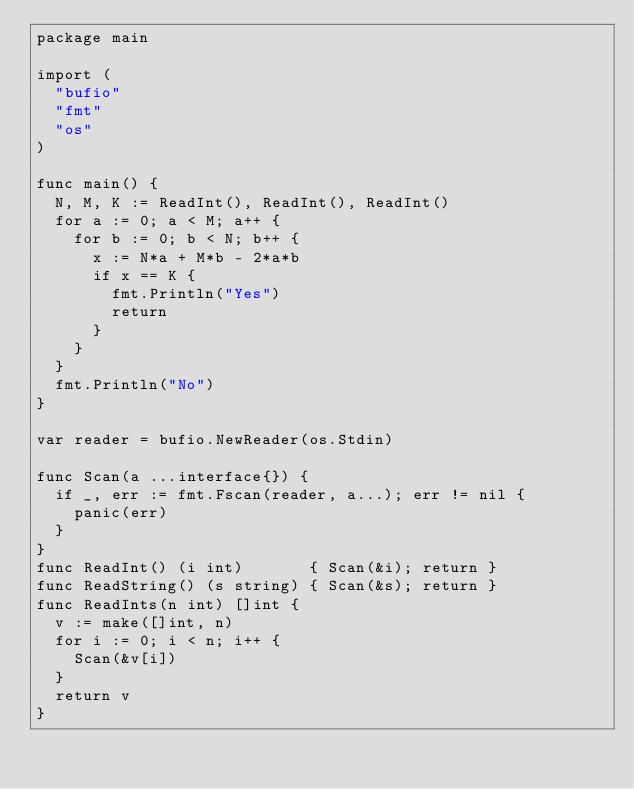<code> <loc_0><loc_0><loc_500><loc_500><_Go_>package main

import (
	"bufio"
	"fmt"
	"os"
)

func main() {
	N, M, K := ReadInt(), ReadInt(), ReadInt()
	for a := 0; a < M; a++ {
		for b := 0; b < N; b++ {
			x := N*a + M*b - 2*a*b
			if x == K {
				fmt.Println("Yes")
				return
			}
		}
	}
	fmt.Println("No")
}

var reader = bufio.NewReader(os.Stdin)

func Scan(a ...interface{}) {
	if _, err := fmt.Fscan(reader, a...); err != nil {
		panic(err)
	}
}
func ReadInt() (i int)       { Scan(&i); return }
func ReadString() (s string) { Scan(&s); return }
func ReadInts(n int) []int {
	v := make([]int, n)
	for i := 0; i < n; i++ {
		Scan(&v[i])
	}
	return v
}
</code> 